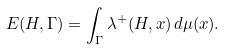<formula> <loc_0><loc_0><loc_500><loc_500>\L E ( H , \Gamma ) = \int _ { \Gamma } \lambda ^ { + } ( H , x ) \, d \mu ( x ) .</formula> 